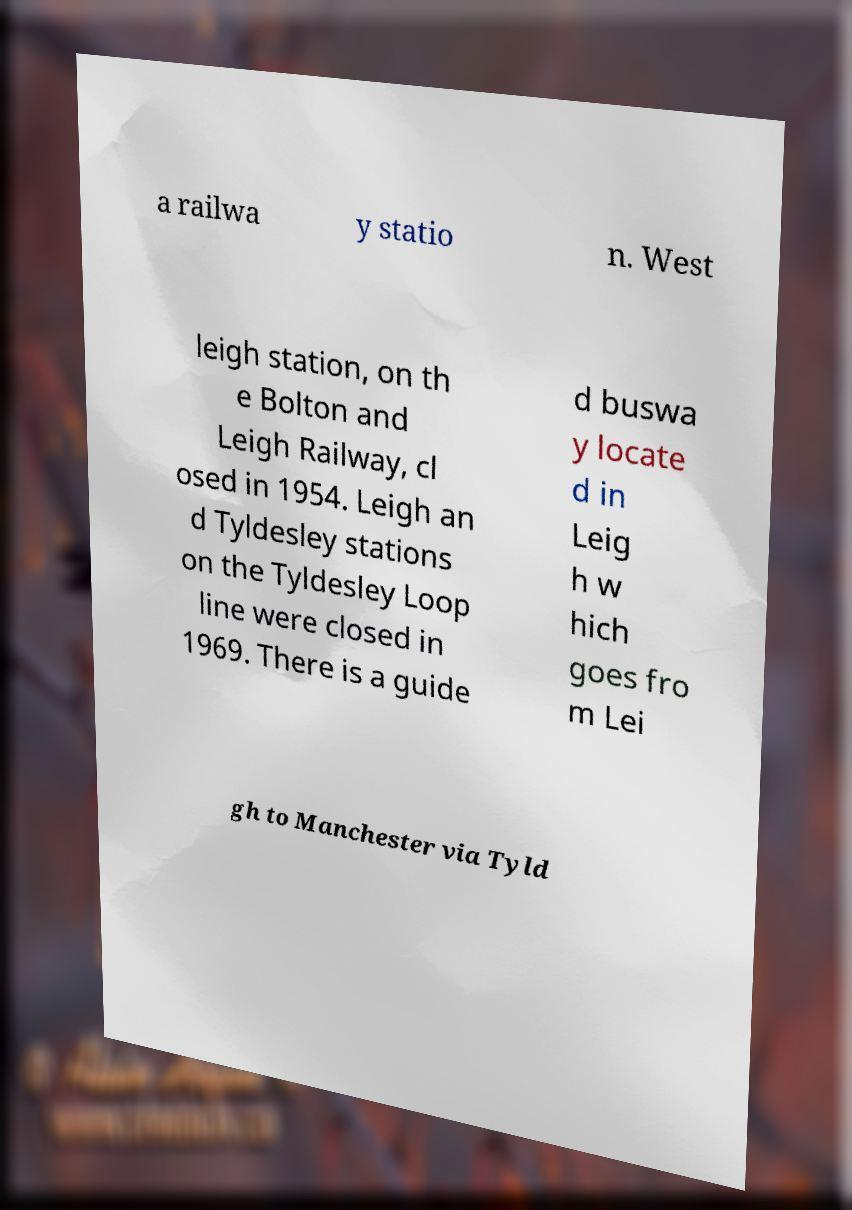Please identify and transcribe the text found in this image. a railwa y statio n. West leigh station, on th e Bolton and Leigh Railway, cl osed in 1954. Leigh an d Tyldesley stations on the Tyldesley Loop line were closed in 1969. There is a guide d buswa y locate d in Leig h w hich goes fro m Lei gh to Manchester via Tyld 